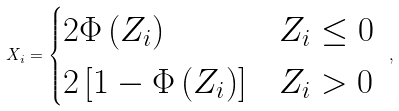Convert formula to latex. <formula><loc_0><loc_0><loc_500><loc_500>X _ { i } = \begin{cases} 2 \Phi \left ( Z _ { i } \right ) & Z _ { i } \leq 0 \\ 2 \left [ 1 - \Phi \left ( Z _ { i } \right ) \right ] & Z _ { i } > 0 \end{cases} \text { } ,</formula> 